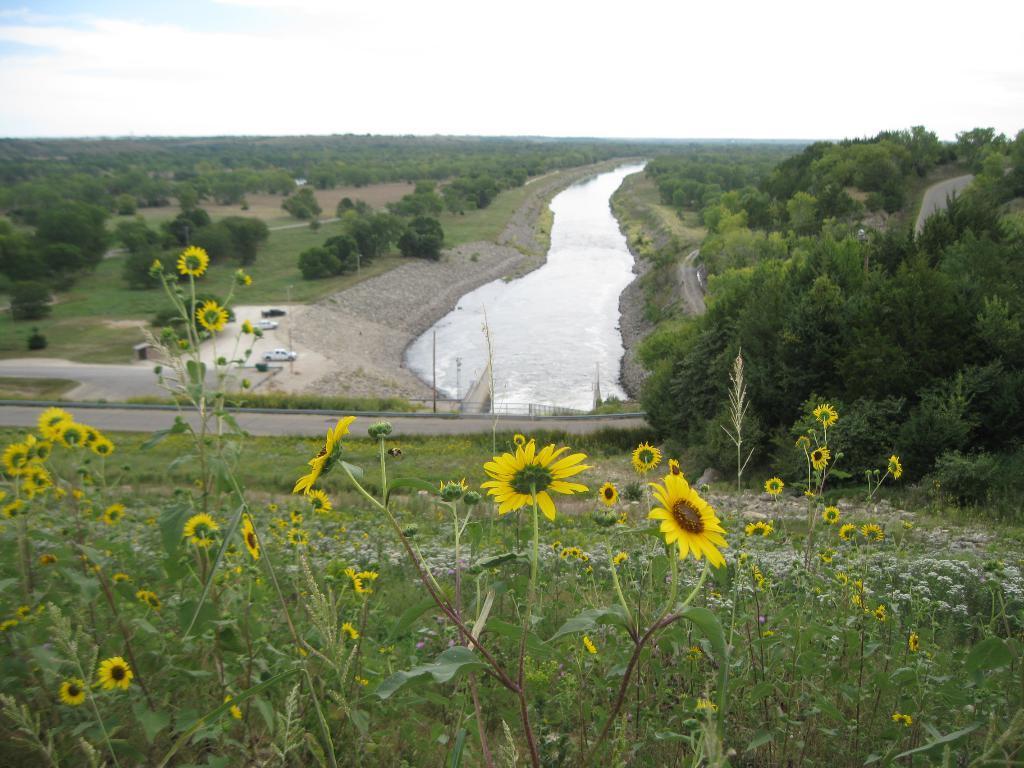How would you summarize this image in a sentence or two? As we can see in the image there is grass, trees, plants, sunflowers and water. In the middle there are cars. At the top there is sky. 